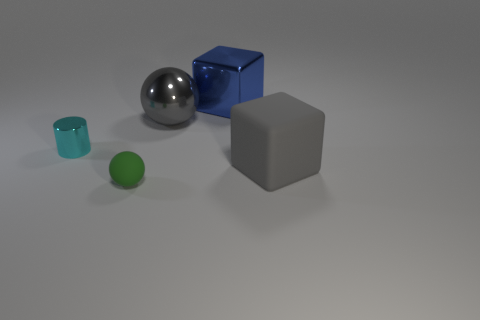Add 2 small green things. How many objects exist? 7 Subtract all cubes. How many objects are left? 3 Subtract all small cyan rubber cylinders. Subtract all shiny cylinders. How many objects are left? 4 Add 1 cylinders. How many cylinders are left? 2 Add 3 large gray matte objects. How many large gray matte objects exist? 4 Subtract 0 red cylinders. How many objects are left? 5 